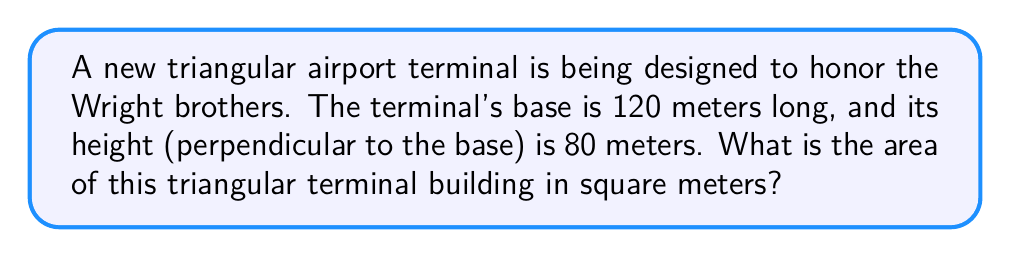Can you solve this math problem? Let's approach this step-by-step:

1) The formula for the area of a triangle is:

   $$A = \frac{1}{2} \times b \times h$$

   Where $A$ is the area, $b$ is the base, and $h$ is the height.

2) We are given:
   - Base (b) = 120 meters
   - Height (h) = 80 meters

3) Let's substitute these values into our formula:

   $$A = \frac{1}{2} \times 120 \times 80$$

4) Now, let's calculate:
   
   $$A = \frac{1}{2} \times 9600 = 4800$$

5) Therefore, the area of the triangular terminal is 4800 square meters.

[asy]
unitsize(0.05cm);
pair A = (0,0), B = (120,0), C = (60,80);
draw(A--B--C--A);
draw(C--(60,0),dashed);
label("120 m", (60,-5), S);
label("80 m", (65,40), E);
label("A", (4800,40));
[/asy]
Answer: 4800 m² 